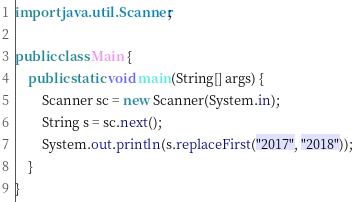Convert code to text. <code><loc_0><loc_0><loc_500><loc_500><_Java_>import java.util.Scanner;

public class Main {
	public static void main(String[] args) {
		Scanner sc = new Scanner(System.in);
		String s = sc.next();
		System.out.println(s.replaceFirst("2017", "2018"));
	}
}</code> 